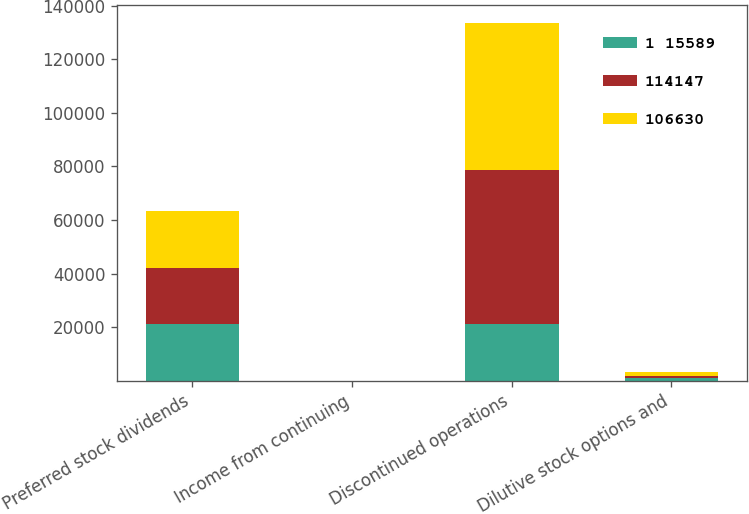<chart> <loc_0><loc_0><loc_500><loc_500><stacked_bar_chart><ecel><fcel>Preferred stock dividends<fcel>Income from continuing<fcel>Discontinued operations<fcel>Dilutive stock options and<nl><fcel>1 15589<fcel>21130<fcel>0.58<fcel>21130<fcel>990<nl><fcel>114147<fcel>21130<fcel>0.7<fcel>57468<fcel>887<nl><fcel>106630<fcel>21130<fcel>0.71<fcel>54893<fcel>1508<nl></chart> 